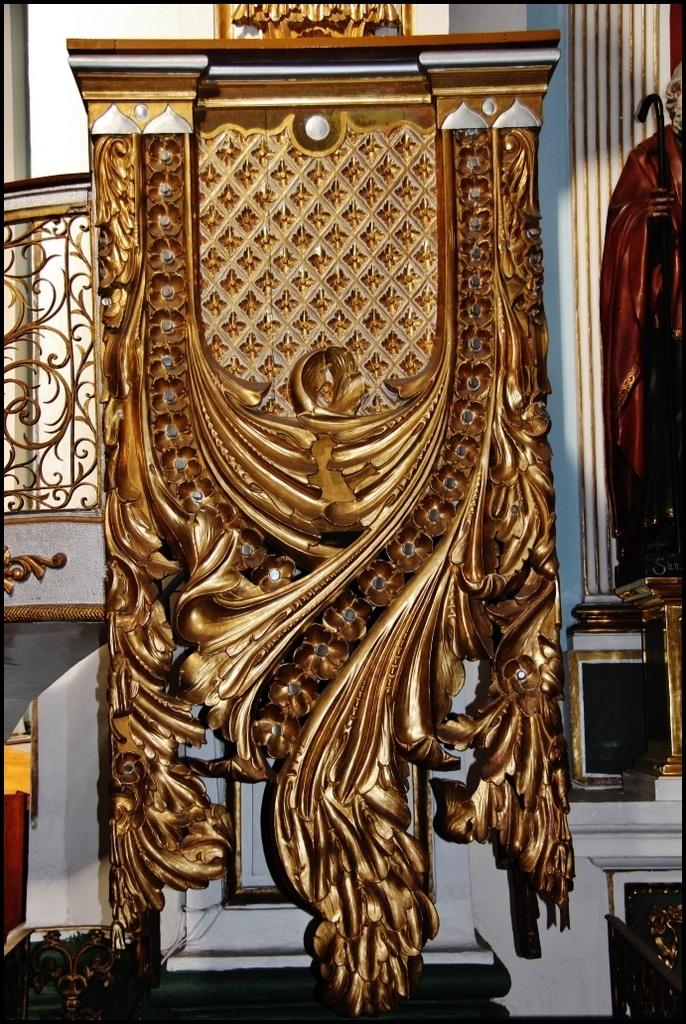What type of structure is visible in the image? There is a building in the image. Can you describe any specific design elements in the image? There is a wall with a design in the image. Is there any source of illumination visible in the image? Yes, there is a light in the image. What is the statue holding in the image? The statue is holding a stick in the image. What type of barrier is present in the image? There is a fence in the image. What page of the book is the statue reading in the image? There is no book or page present in the image; the statue is holding a stick. 